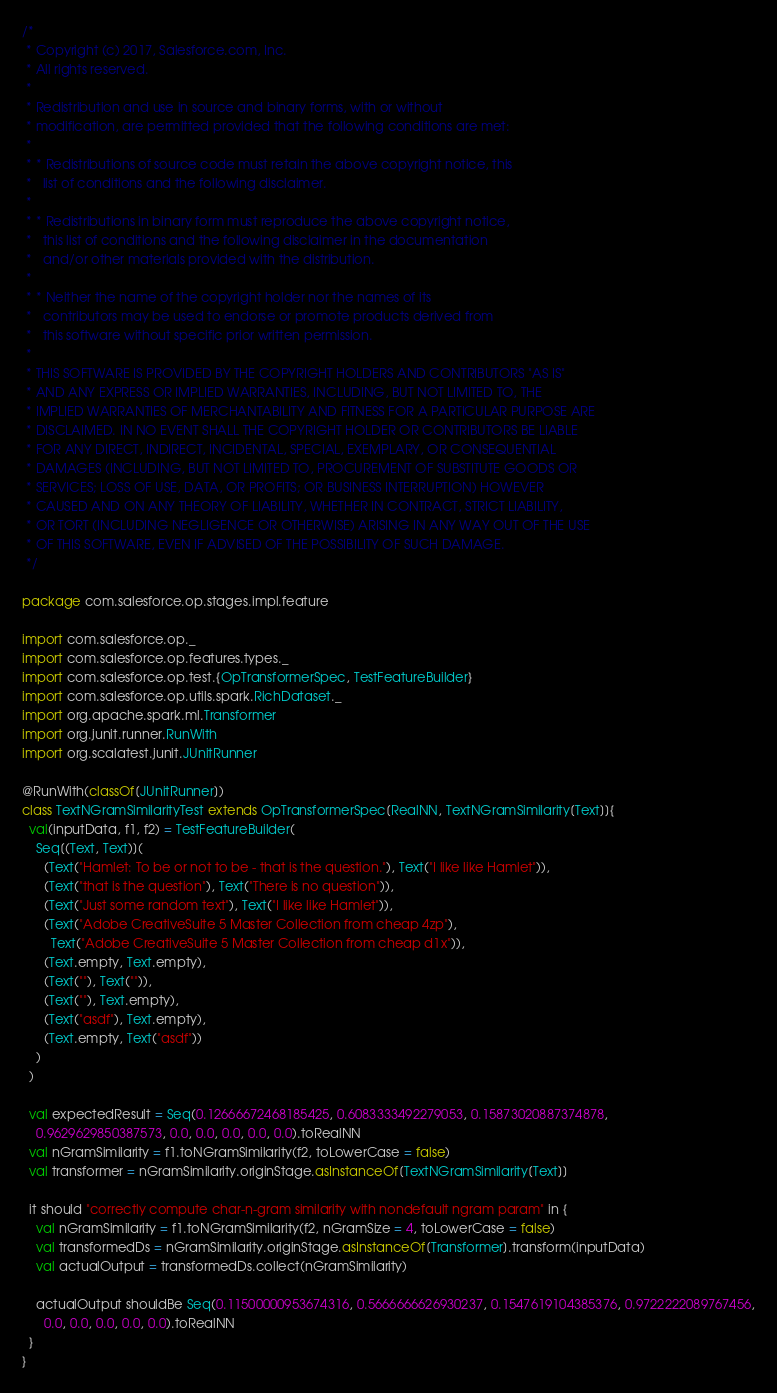<code> <loc_0><loc_0><loc_500><loc_500><_Scala_>/*
 * Copyright (c) 2017, Salesforce.com, Inc.
 * All rights reserved.
 *
 * Redistribution and use in source and binary forms, with or without
 * modification, are permitted provided that the following conditions are met:
 *
 * * Redistributions of source code must retain the above copyright notice, this
 *   list of conditions and the following disclaimer.
 *
 * * Redistributions in binary form must reproduce the above copyright notice,
 *   this list of conditions and the following disclaimer in the documentation
 *   and/or other materials provided with the distribution.
 *
 * * Neither the name of the copyright holder nor the names of its
 *   contributors may be used to endorse or promote products derived from
 *   this software without specific prior written permission.
 *
 * THIS SOFTWARE IS PROVIDED BY THE COPYRIGHT HOLDERS AND CONTRIBUTORS "AS IS"
 * AND ANY EXPRESS OR IMPLIED WARRANTIES, INCLUDING, BUT NOT LIMITED TO, THE
 * IMPLIED WARRANTIES OF MERCHANTABILITY AND FITNESS FOR A PARTICULAR PURPOSE ARE
 * DISCLAIMED. IN NO EVENT SHALL THE COPYRIGHT HOLDER OR CONTRIBUTORS BE LIABLE
 * FOR ANY DIRECT, INDIRECT, INCIDENTAL, SPECIAL, EXEMPLARY, OR CONSEQUENTIAL
 * DAMAGES (INCLUDING, BUT NOT LIMITED TO, PROCUREMENT OF SUBSTITUTE GOODS OR
 * SERVICES; LOSS OF USE, DATA, OR PROFITS; OR BUSINESS INTERRUPTION) HOWEVER
 * CAUSED AND ON ANY THEORY OF LIABILITY, WHETHER IN CONTRACT, STRICT LIABILITY,
 * OR TORT (INCLUDING NEGLIGENCE OR OTHERWISE) ARISING IN ANY WAY OUT OF THE USE
 * OF THIS SOFTWARE, EVEN IF ADVISED OF THE POSSIBILITY OF SUCH DAMAGE.
 */

package com.salesforce.op.stages.impl.feature

import com.salesforce.op._
import com.salesforce.op.features.types._
import com.salesforce.op.test.{OpTransformerSpec, TestFeatureBuilder}
import com.salesforce.op.utils.spark.RichDataset._
import org.apache.spark.ml.Transformer
import org.junit.runner.RunWith
import org.scalatest.junit.JUnitRunner

@RunWith(classOf[JUnitRunner])
class TextNGramSimilarityTest extends OpTransformerSpec[RealNN, TextNGramSimilarity[Text]]{
  val(inputData, f1, f2) = TestFeatureBuilder(
    Seq[(Text, Text)](
      (Text("Hamlet: To be or not to be - that is the question."), Text("I like like Hamlet")),
      (Text("that is the question"), Text("There is no question")),
      (Text("Just some random text"), Text("I like like Hamlet")),
      (Text("Adobe CreativeSuite 5 Master Collection from cheap 4zp"),
        Text("Adobe CreativeSuite 5 Master Collection from cheap d1x")),
      (Text.empty, Text.empty),
      (Text(""), Text("")),
      (Text(""), Text.empty),
      (Text("asdf"), Text.empty),
      (Text.empty, Text("asdf"))
    )
  )

  val expectedResult = Seq(0.12666672468185425, 0.6083333492279053, 0.15873020887374878,
    0.9629629850387573, 0.0, 0.0, 0.0, 0.0, 0.0).toRealNN
  val nGramSimilarity = f1.toNGramSimilarity(f2, toLowerCase = false)
  val transformer = nGramSimilarity.originStage.asInstanceOf[TextNGramSimilarity[Text]]

  it should "correctly compute char-n-gram similarity with nondefault ngram param" in {
    val nGramSimilarity = f1.toNGramSimilarity(f2, nGramSize = 4, toLowerCase = false)
    val transformedDs = nGramSimilarity.originStage.asInstanceOf[Transformer].transform(inputData)
    val actualOutput = transformedDs.collect(nGramSimilarity)

    actualOutput shouldBe Seq(0.11500000953674316, 0.5666666626930237, 0.1547619104385376, 0.9722222089767456,
      0.0, 0.0, 0.0, 0.0, 0.0).toRealNN
  }
}
</code> 